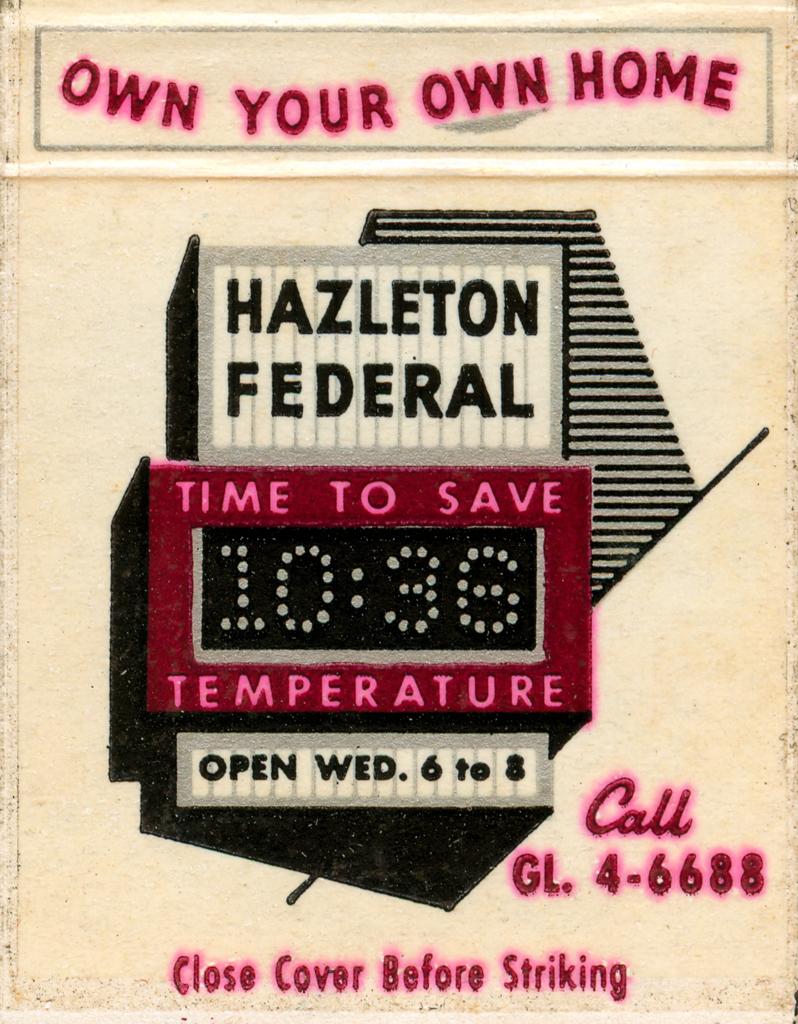What's the phone number to call?
Make the answer very short. 4-6688. Own your own what?
Provide a short and direct response. Home. 